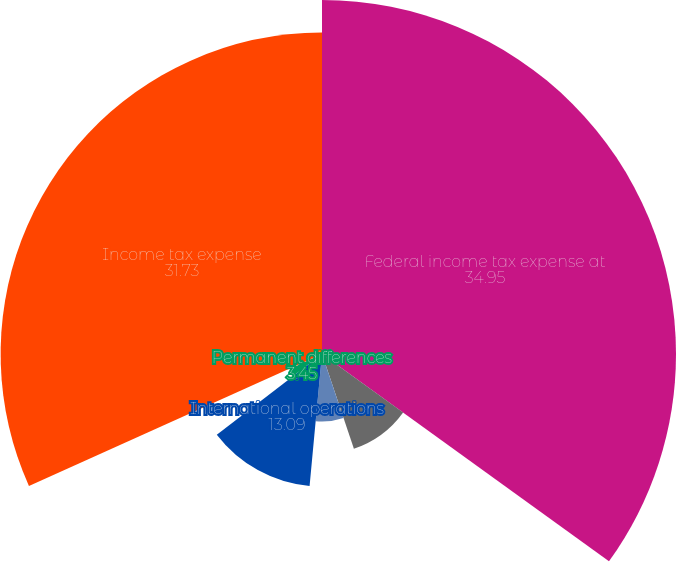Convert chart to OTSL. <chart><loc_0><loc_0><loc_500><loc_500><pie_chart><fcel>Federal income tax expense at<fcel>US state income tax expense<fcel>US manufacturing deduction<fcel>International operations<fcel>Permanent differences<fcel>Other net<fcel>Income tax expense<nl><fcel>34.95%<fcel>9.88%<fcel>6.66%<fcel>13.09%<fcel>3.45%<fcel>0.23%<fcel>31.73%<nl></chart> 